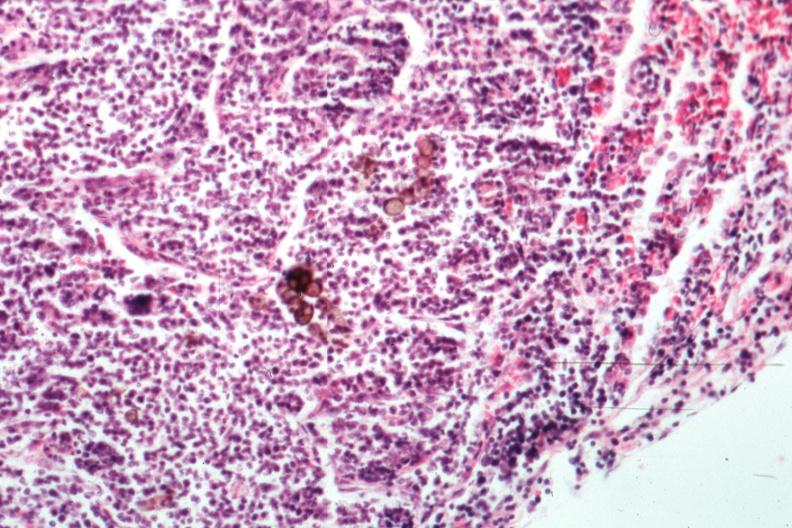s burkitts lymphoma present?
Answer the question using a single word or phrase. No 